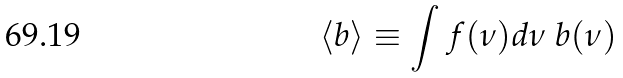Convert formula to latex. <formula><loc_0><loc_0><loc_500><loc_500>\left \langle b \right \rangle \equiv \int f ( \nu ) d \nu \ b ( \nu )</formula> 